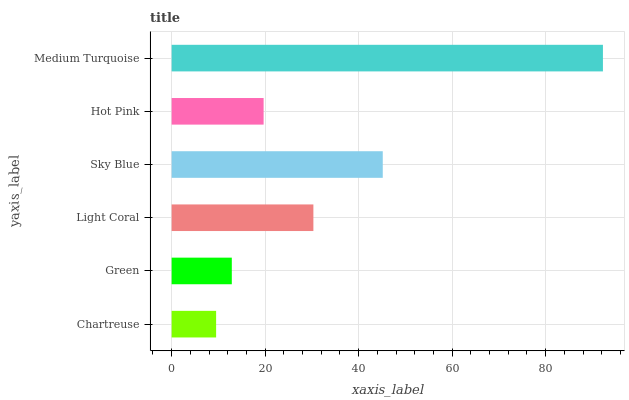Is Chartreuse the minimum?
Answer yes or no. Yes. Is Medium Turquoise the maximum?
Answer yes or no. Yes. Is Green the minimum?
Answer yes or no. No. Is Green the maximum?
Answer yes or no. No. Is Green greater than Chartreuse?
Answer yes or no. Yes. Is Chartreuse less than Green?
Answer yes or no. Yes. Is Chartreuse greater than Green?
Answer yes or no. No. Is Green less than Chartreuse?
Answer yes or no. No. Is Light Coral the high median?
Answer yes or no. Yes. Is Hot Pink the low median?
Answer yes or no. Yes. Is Sky Blue the high median?
Answer yes or no. No. Is Light Coral the low median?
Answer yes or no. No. 